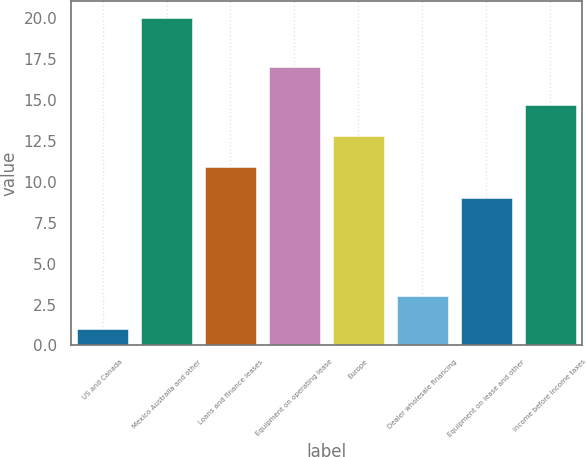Convert chart to OTSL. <chart><loc_0><loc_0><loc_500><loc_500><bar_chart><fcel>US and Canada<fcel>Mexico Australia and other<fcel>Loans and finance leases<fcel>Equipment on operating lease<fcel>Europe<fcel>Dealer wholesale financing<fcel>Equipment on lease and other<fcel>Income before income taxes<nl><fcel>1<fcel>20<fcel>10.9<fcel>17<fcel>12.8<fcel>3<fcel>9<fcel>14.7<nl></chart> 